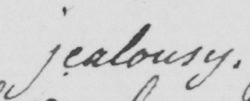Transcribe the text shown in this historical manuscript line. jealousy 